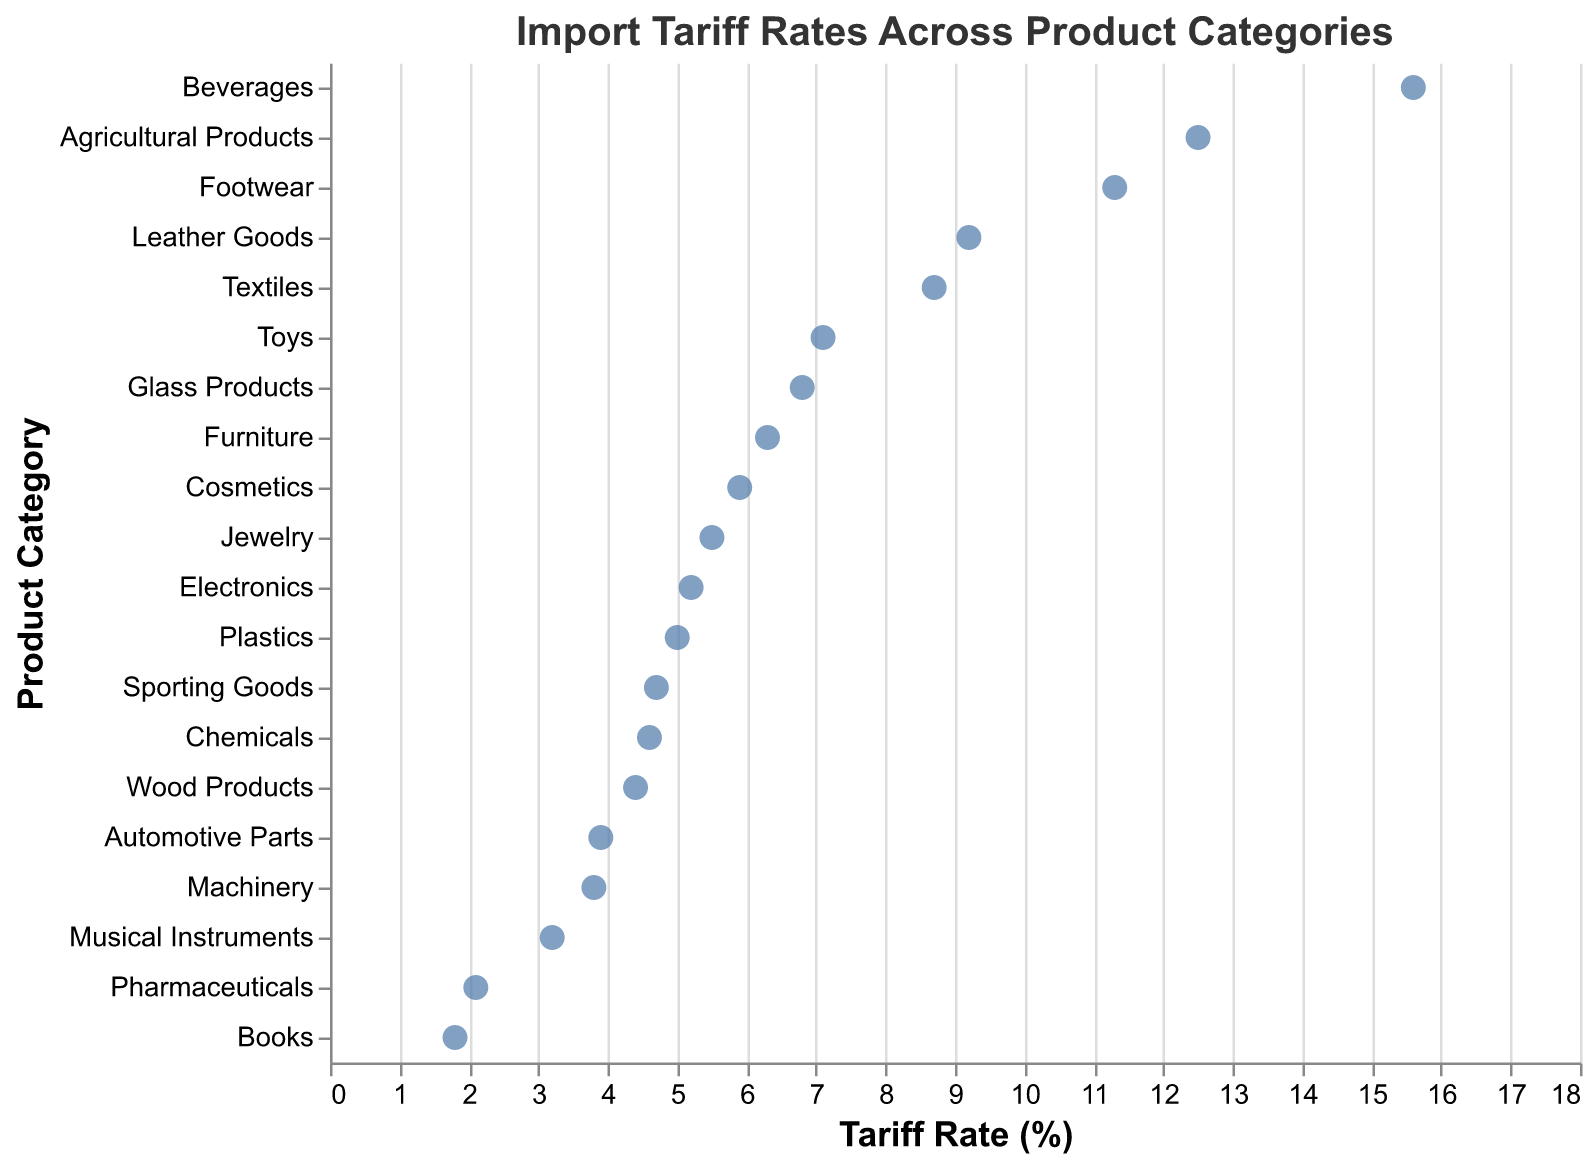What's the title of the plot? The title of the plot is usually displayed at the top. In this plot, it's clearly stated in a larger font size.
Answer: Import Tariff Rates Across Product Categories How many product categories are represented in the plot? Each point on the plot corresponds to a unique product category, and by counting these points, which we can also verify by the y-axis labels, we find that there are 20 categories.
Answer: 20 Which product category has the highest tariff rate? By observing the far-right end of the x-axis and tracing it back to the y-axis, we find that "Beverages" is the product category with the highest tariff rate.
Answer: Beverages What is the tariff rate for Pharmaceuticals? To find this, locate "Pharmaceuticals" on the y-axis and trace it horizontally to the x-axis where the corresponding point is situated.
Answer: 2.1% Which category has a lower tariff rate, Footwear or Electronics? By comparing the positions of points for Footwear and Electronics on the x-axis, Footwear is further to the right than Electronics, indicating a higher tariff rate for Footwear. Hence, Electronics has a lower tariff rate.
Answer: Electronics What is the difference in tariff rates between the categories with the highest and lowest rates? The highest tariff rate is for Beverages (15.6%), and the lowest is for Books (1.8%). Subtracting these gives 15.6% - 1.8% = 13.8%.
Answer: 13.8% What is the average tariff rate of all product categories? To find the average, sum all the given tariff rates and divide by the number of categories. The sum is 128.2% and there are 20 categories. Thus, the average is 128.2/20 = 6.41%.
Answer: 6.41% Which products have tariff rates between 5% and 10%? By locating the points between the 5% and 10% marks on the x-axis, the corresponding product categories are Electronics, Textiles, Furniture, Toys, Cosmetics, Jewelry, Glass Products, and Leather Goods.
Answer: Electronics, Textiles, Furniture, Toys, Cosmetics, Jewelry, Glass Products, Leather Goods What is the combined tariff rate for Agricultural Products, Footwear, and Beverages? Add the rates for these categories: 12.5% (Agricultural Products) + 11.3% (Footwear) + 15.6% (Beverages). The combined tariff rate is 39.4%.
Answer: 39.4% Which product categories have a tariff rate less than 3%? Locate the points on the plot that are to the left of the 3% mark on the x-axis. The corresponding categories are Pharmaceuticals and Books.
Answer: Pharmaceuticals, Books 